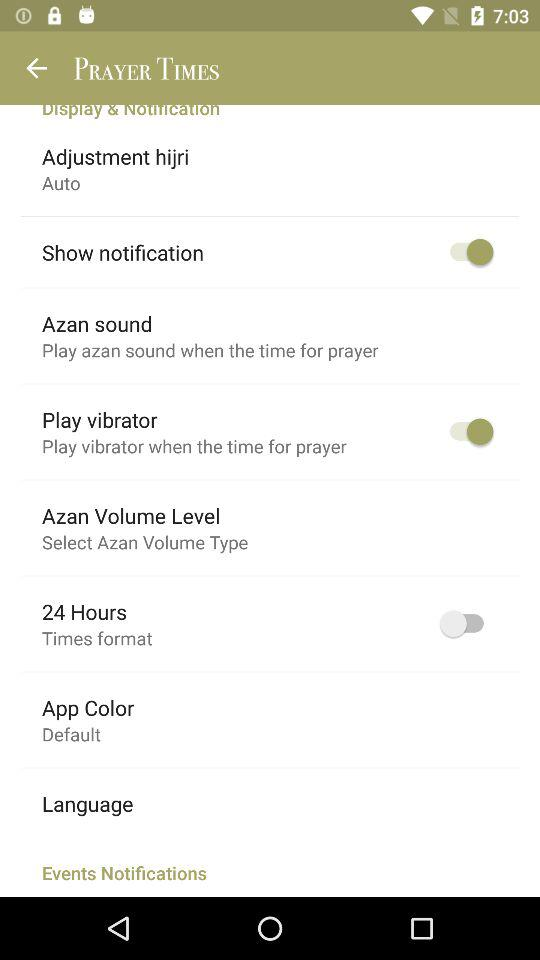What is the setting for the app color? The setting for the app color is "Default". 